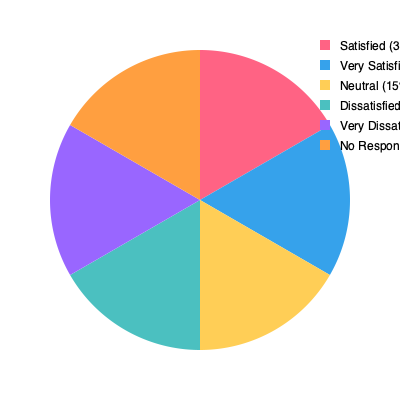As a middle manager analyzing this employee satisfaction pie chart, what psychological insight can be drawn from the data, and how might it inform your approach to improving overall job satisfaction in your department? To answer this question, let's break down the data and its implications:

1. Satisfaction levels:
   - Satisfied: 30%
   - Very Satisfied: 25%
   - Neutral: 15%
   - Dissatisfied: 12%
   - Very Dissatisfied: 10%
   - No Response: 8%

2. Psychological insight:
   The data shows a bimodal distribution, with a majority of employees (55%) feeling satisfied or very satisfied, and a smaller but significant group (22%) feeling dissatisfied or very dissatisfied. This suggests a polarization in employee experiences.

3. Implications:
   a) The presence of a neutral group (15%) and non-respondents (8%) indicates potential for improvement.
   b) The dissatisfied minority could negatively impact overall team morale and productivity.

4. Approach to improving job satisfaction:
   a) Conduct in-depth interviews or focus groups to understand the factors contributing to both satisfaction and dissatisfaction.
   b) Implement targeted interventions based on findings, such as addressing specific pain points for dissatisfied employees.
   c) Engage the neutral group to understand what would move them towards satisfaction.
   d) Leverage satisfied employees as mentors or to share best practices.
   e) Address the non-response group to ensure all voices are heard and accounted for.

5. Psychological principles to apply:
   a) Self-Determination Theory: Focus on enhancing autonomy, competence, and relatedness to boost intrinsic motivation.
   b) Social Comparison Theory: Manage perceptions of equity and fairness across the organization.
   c) Positive Psychology: Build on existing strengths and positive experiences to cultivate a more satisfying work environment.

By applying these psychological insights and taking a data-driven approach to improving job satisfaction, you can work towards reducing the polarization and increasing overall employee satisfaction in your department.
Answer: Address polarization by targeting dissatisfied employees, engaging neutral groups, and leveraging satisfied employees to improve overall job satisfaction through data-driven interventions and psychological principles. 